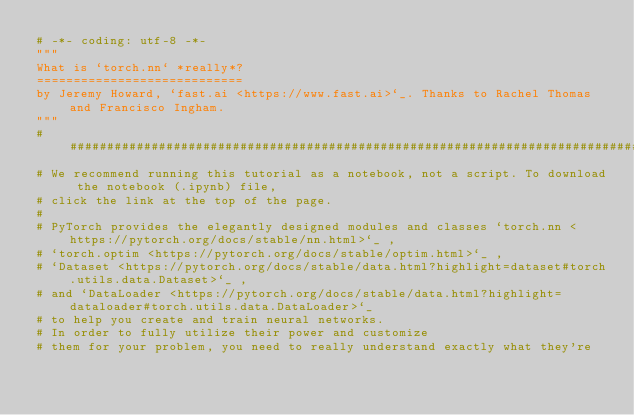<code> <loc_0><loc_0><loc_500><loc_500><_Python_># -*- coding: utf-8 -*-
"""
What is `torch.nn` *really*?
============================
by Jeremy Howard, `fast.ai <https://www.fast.ai>`_. Thanks to Rachel Thomas and Francisco Ingham.
"""
###############################################################################
# We recommend running this tutorial as a notebook, not a script. To download the notebook (.ipynb) file,
# click the link at the top of the page.
#
# PyTorch provides the elegantly designed modules and classes `torch.nn <https://pytorch.org/docs/stable/nn.html>`_ ,
# `torch.optim <https://pytorch.org/docs/stable/optim.html>`_ ,
# `Dataset <https://pytorch.org/docs/stable/data.html?highlight=dataset#torch.utils.data.Dataset>`_ ,
# and `DataLoader <https://pytorch.org/docs/stable/data.html?highlight=dataloader#torch.utils.data.DataLoader>`_
# to help you create and train neural networks.
# In order to fully utilize their power and customize
# them for your problem, you need to really understand exactly what they're</code> 